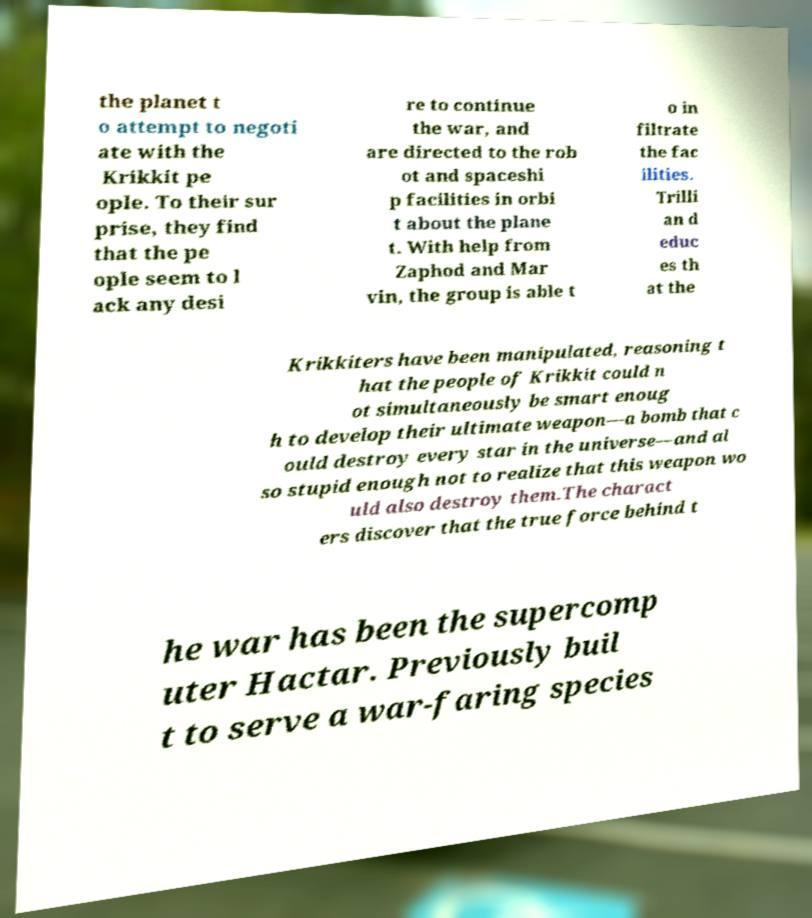Can you read and provide the text displayed in the image?This photo seems to have some interesting text. Can you extract and type it out for me? the planet t o attempt to negoti ate with the Krikkit pe ople. To their sur prise, they find that the pe ople seem to l ack any desi re to continue the war, and are directed to the rob ot and spaceshi p facilities in orbi t about the plane t. With help from Zaphod and Mar vin, the group is able t o in filtrate the fac ilities. Trilli an d educ es th at the Krikkiters have been manipulated, reasoning t hat the people of Krikkit could n ot simultaneously be smart enoug h to develop their ultimate weapon—a bomb that c ould destroy every star in the universe—and al so stupid enough not to realize that this weapon wo uld also destroy them.The charact ers discover that the true force behind t he war has been the supercomp uter Hactar. Previously buil t to serve a war-faring species 